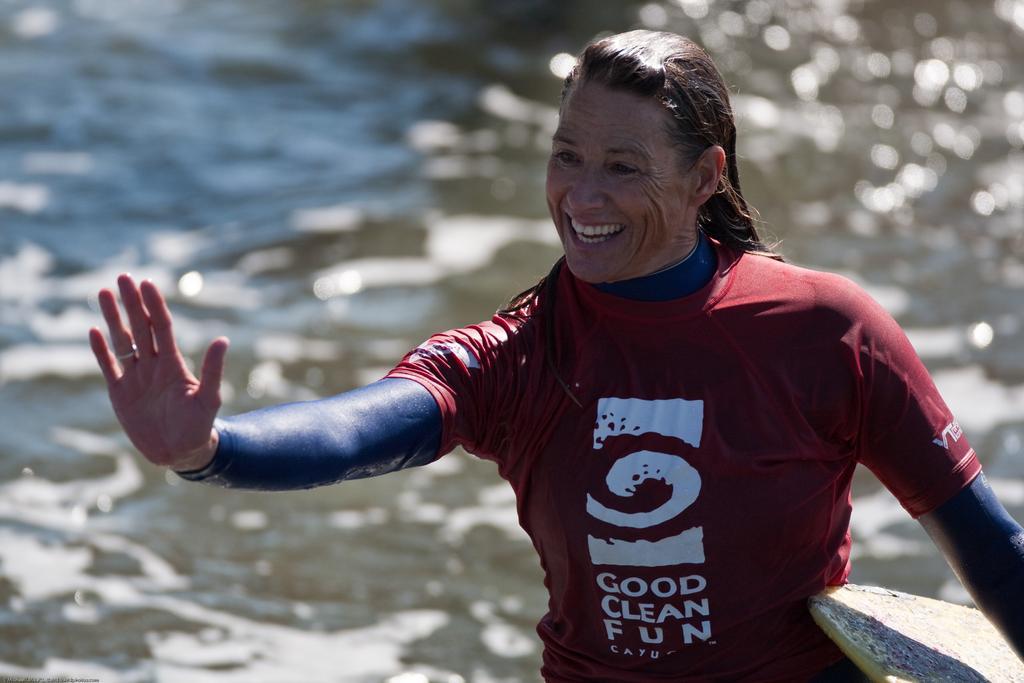How would you summarize this image in a sentence or two? In this image I can see a woman is showing her hand, she is wearing a red color t-shirt. It looks like she is holding the surfboard in her hand. At the back side there is the water. 